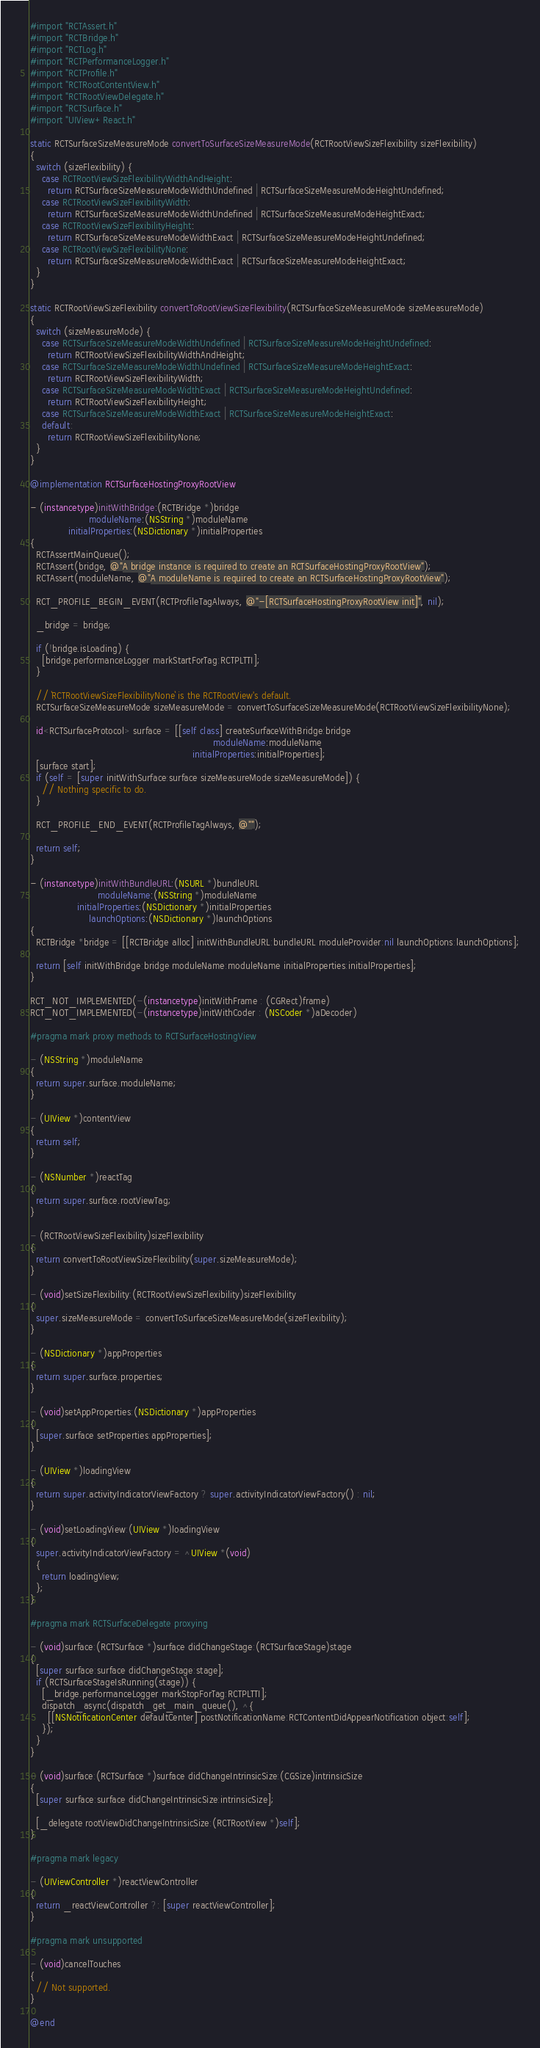<code> <loc_0><loc_0><loc_500><loc_500><_ObjectiveC_>
#import "RCTAssert.h"
#import "RCTBridge.h"
#import "RCTLog.h"
#import "RCTPerformanceLogger.h"
#import "RCTProfile.h"
#import "RCTRootContentView.h"
#import "RCTRootViewDelegate.h"
#import "RCTSurface.h"
#import "UIView+React.h"

static RCTSurfaceSizeMeasureMode convertToSurfaceSizeMeasureMode(RCTRootViewSizeFlexibility sizeFlexibility)
{
  switch (sizeFlexibility) {
    case RCTRootViewSizeFlexibilityWidthAndHeight:
      return RCTSurfaceSizeMeasureModeWidthUndefined | RCTSurfaceSizeMeasureModeHeightUndefined;
    case RCTRootViewSizeFlexibilityWidth:
      return RCTSurfaceSizeMeasureModeWidthUndefined | RCTSurfaceSizeMeasureModeHeightExact;
    case RCTRootViewSizeFlexibilityHeight:
      return RCTSurfaceSizeMeasureModeWidthExact | RCTSurfaceSizeMeasureModeHeightUndefined;
    case RCTRootViewSizeFlexibilityNone:
      return RCTSurfaceSizeMeasureModeWidthExact | RCTSurfaceSizeMeasureModeHeightExact;
  }
}

static RCTRootViewSizeFlexibility convertToRootViewSizeFlexibility(RCTSurfaceSizeMeasureMode sizeMeasureMode)
{
  switch (sizeMeasureMode) {
    case RCTSurfaceSizeMeasureModeWidthUndefined | RCTSurfaceSizeMeasureModeHeightUndefined:
      return RCTRootViewSizeFlexibilityWidthAndHeight;
    case RCTSurfaceSizeMeasureModeWidthUndefined | RCTSurfaceSizeMeasureModeHeightExact:
      return RCTRootViewSizeFlexibilityWidth;
    case RCTSurfaceSizeMeasureModeWidthExact | RCTSurfaceSizeMeasureModeHeightUndefined:
      return RCTRootViewSizeFlexibilityHeight;
    case RCTSurfaceSizeMeasureModeWidthExact | RCTSurfaceSizeMeasureModeHeightExact:
    default:
      return RCTRootViewSizeFlexibilityNone;
  }
}

@implementation RCTSurfaceHostingProxyRootView

- (instancetype)initWithBridge:(RCTBridge *)bridge
                    moduleName:(NSString *)moduleName
             initialProperties:(NSDictionary *)initialProperties
{
  RCTAssertMainQueue();
  RCTAssert(bridge, @"A bridge instance is required to create an RCTSurfaceHostingProxyRootView");
  RCTAssert(moduleName, @"A moduleName is required to create an RCTSurfaceHostingProxyRootView");

  RCT_PROFILE_BEGIN_EVENT(RCTProfileTagAlways, @"-[RCTSurfaceHostingProxyRootView init]", nil);

  _bridge = bridge;

  if (!bridge.isLoading) {
    [bridge.performanceLogger markStartForTag:RCTPLTTI];
  }

  // `RCTRootViewSizeFlexibilityNone` is the RCTRootView's default.
  RCTSurfaceSizeMeasureMode sizeMeasureMode = convertToSurfaceSizeMeasureMode(RCTRootViewSizeFlexibilityNone);

  id<RCTSurfaceProtocol> surface = [[self class] createSurfaceWithBridge:bridge
                                                              moduleName:moduleName
                                                       initialProperties:initialProperties];
  [surface start];
  if (self = [super initWithSurface:surface sizeMeasureMode:sizeMeasureMode]) {
    // Nothing specific to do.
  }

  RCT_PROFILE_END_EVENT(RCTProfileTagAlways, @"");

  return self;
}

- (instancetype)initWithBundleURL:(NSURL *)bundleURL
                       moduleName:(NSString *)moduleName
                initialProperties:(NSDictionary *)initialProperties
                    launchOptions:(NSDictionary *)launchOptions
{
  RCTBridge *bridge = [[RCTBridge alloc] initWithBundleURL:bundleURL moduleProvider:nil launchOptions:launchOptions];

  return [self initWithBridge:bridge moduleName:moduleName initialProperties:initialProperties];
}

RCT_NOT_IMPLEMENTED(-(instancetype)initWithFrame : (CGRect)frame)
RCT_NOT_IMPLEMENTED(-(instancetype)initWithCoder : (NSCoder *)aDecoder)

#pragma mark proxy methods to RCTSurfaceHostingView

- (NSString *)moduleName
{
  return super.surface.moduleName;
}

- (UIView *)contentView
{
  return self;
}

- (NSNumber *)reactTag
{
  return super.surface.rootViewTag;
}

- (RCTRootViewSizeFlexibility)sizeFlexibility
{
  return convertToRootViewSizeFlexibility(super.sizeMeasureMode);
}

- (void)setSizeFlexibility:(RCTRootViewSizeFlexibility)sizeFlexibility
{
  super.sizeMeasureMode = convertToSurfaceSizeMeasureMode(sizeFlexibility);
}

- (NSDictionary *)appProperties
{
  return super.surface.properties;
}

- (void)setAppProperties:(NSDictionary *)appProperties
{
  [super.surface setProperties:appProperties];
}

- (UIView *)loadingView
{
  return super.activityIndicatorViewFactory ? super.activityIndicatorViewFactory() : nil;
}

- (void)setLoadingView:(UIView *)loadingView
{
  super.activityIndicatorViewFactory = ^UIView *(void)
  {
    return loadingView;
  };
}

#pragma mark RCTSurfaceDelegate proxying

- (void)surface:(RCTSurface *)surface didChangeStage:(RCTSurfaceStage)stage
{
  [super surface:surface didChangeStage:stage];
  if (RCTSurfaceStageIsRunning(stage)) {
    [_bridge.performanceLogger markStopForTag:RCTPLTTI];
    dispatch_async(dispatch_get_main_queue(), ^{
      [[NSNotificationCenter defaultCenter] postNotificationName:RCTContentDidAppearNotification object:self];
    });
  }
}

- (void)surface:(RCTSurface *)surface didChangeIntrinsicSize:(CGSize)intrinsicSize
{
  [super surface:surface didChangeIntrinsicSize:intrinsicSize];

  [_delegate rootViewDidChangeIntrinsicSize:(RCTRootView *)self];
}

#pragma mark legacy

- (UIViewController *)reactViewController
{
  return _reactViewController ?: [super reactViewController];
}

#pragma mark unsupported

- (void)cancelTouches
{
  // Not supported.
}

@end
</code> 